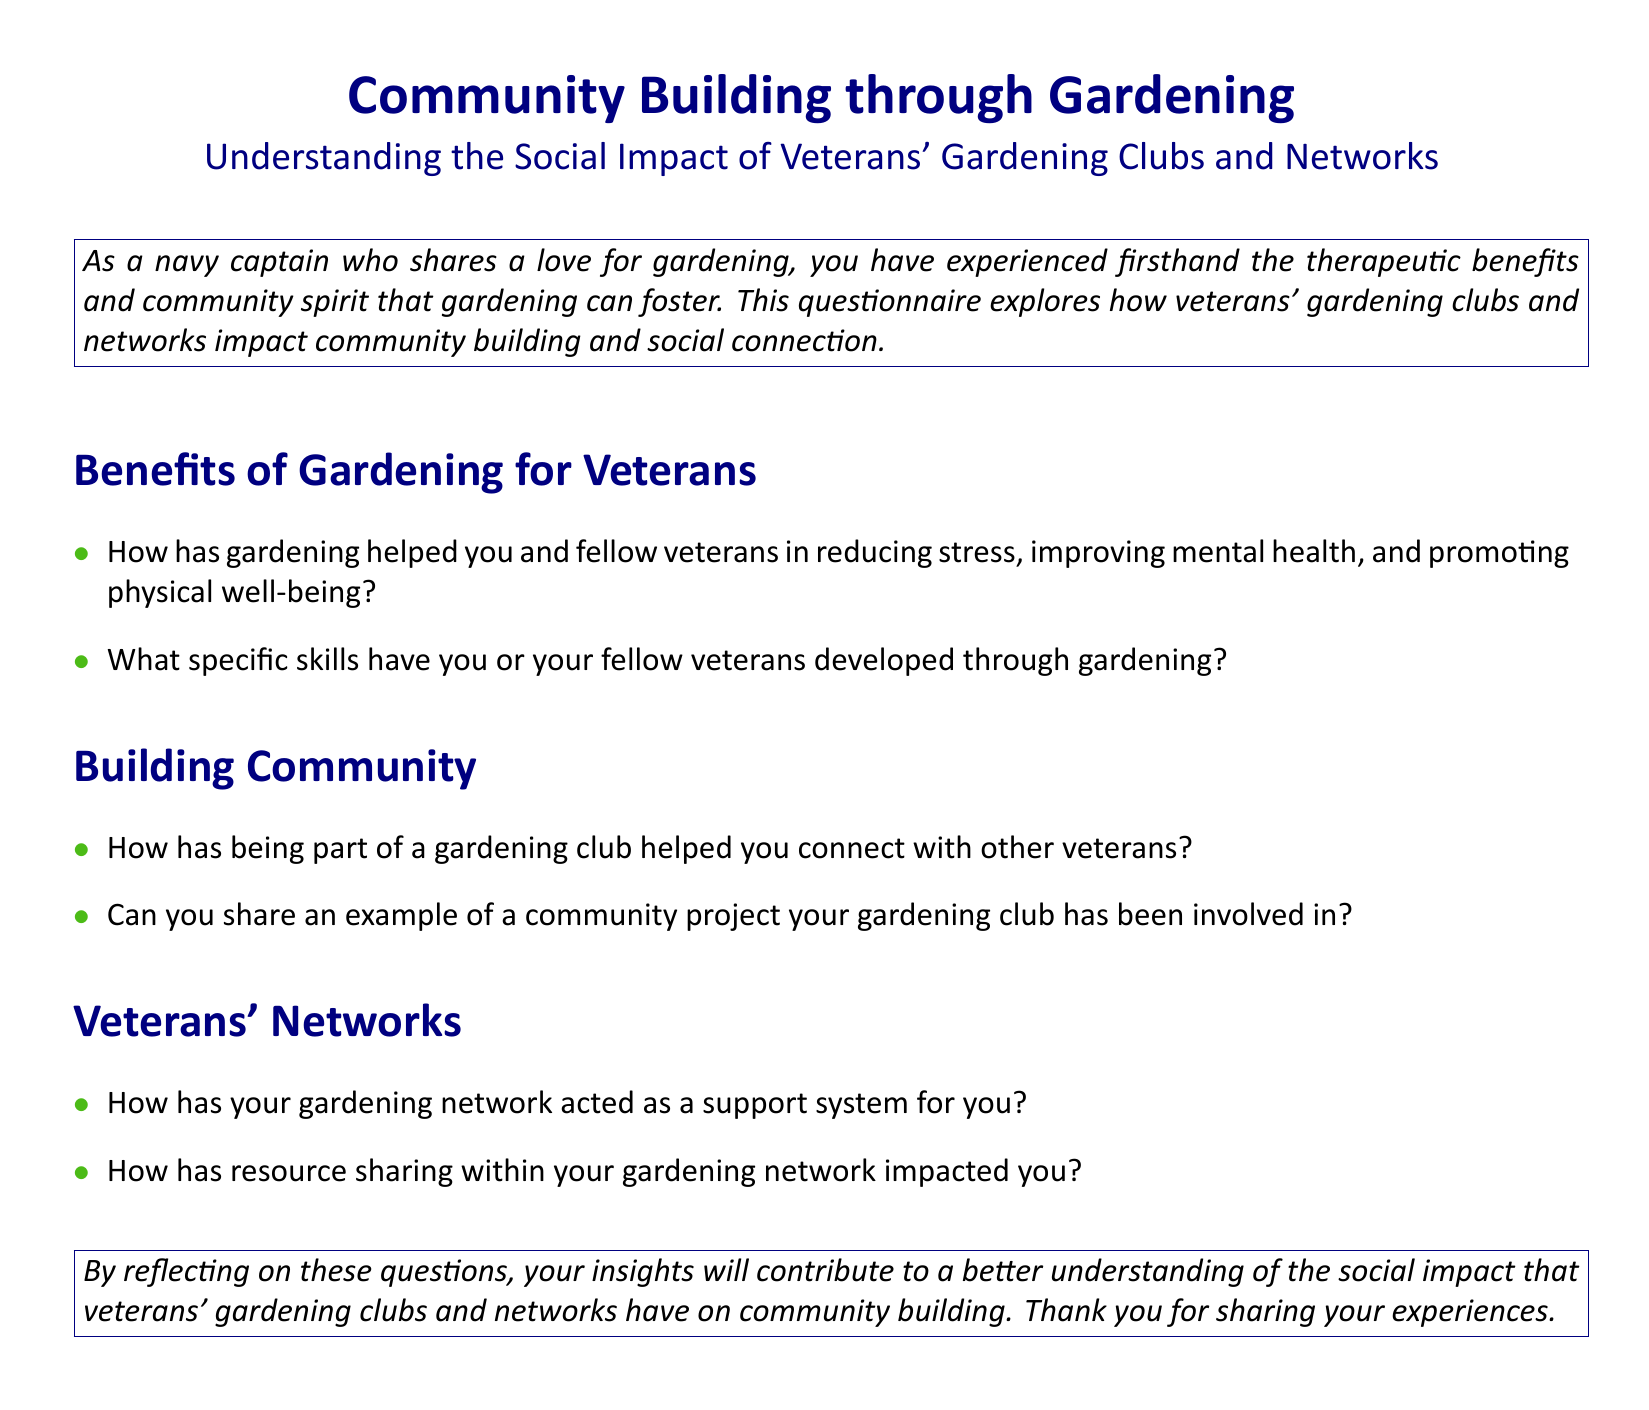What is the main topic of the questionnaire? The main topic focuses on the social impact of veterans' gardening clubs and networks on community building.
Answer: Community Building through Gardening Who is the intended audience for the questionnaire? The intended audience includes veterans who participate in gardening clubs and networks.
Answer: Veterans What color is used for the section titles? The section titles are colored in navy blue as indicated by the document formatting.
Answer: Navy blue What is one benefit of gardening mentioned for veterans? The questionnaire highlights benefits such as stress reduction and improved mental health for veterans participating in gardening activities.
Answer: Reducing stress What is a community project-related question included in the questionnaire? The questionnaire asks for examples of community projects that a gardening club has been involved in.
Answer: Can you share an example of a community project your gardening club has been involved in? What do veterans’ gardening networks provide according to the document? Veterans’ gardening networks act as a support system as mentioned in the questionnaire.
Answer: Support system How does the questionnaire suggest sharing insights will contribute to the understanding of social impact? The questionnaire implies that by reflecting on the questions, respondents' insights will help better understand the social impact.
Answer: Understanding social impact What is one specific skill the questionnaire inquires about that veterans may develop through gardening? One inquiry is regarding specific skills veterans may develop through gardening activities as highlighted in the document.
Answer: Specific skills developed How has resource sharing been addressed in the questionnaire? The questionnaire includes a question on how resource sharing within a gardening network impacts individuals.
Answer: Impact of resource sharing 